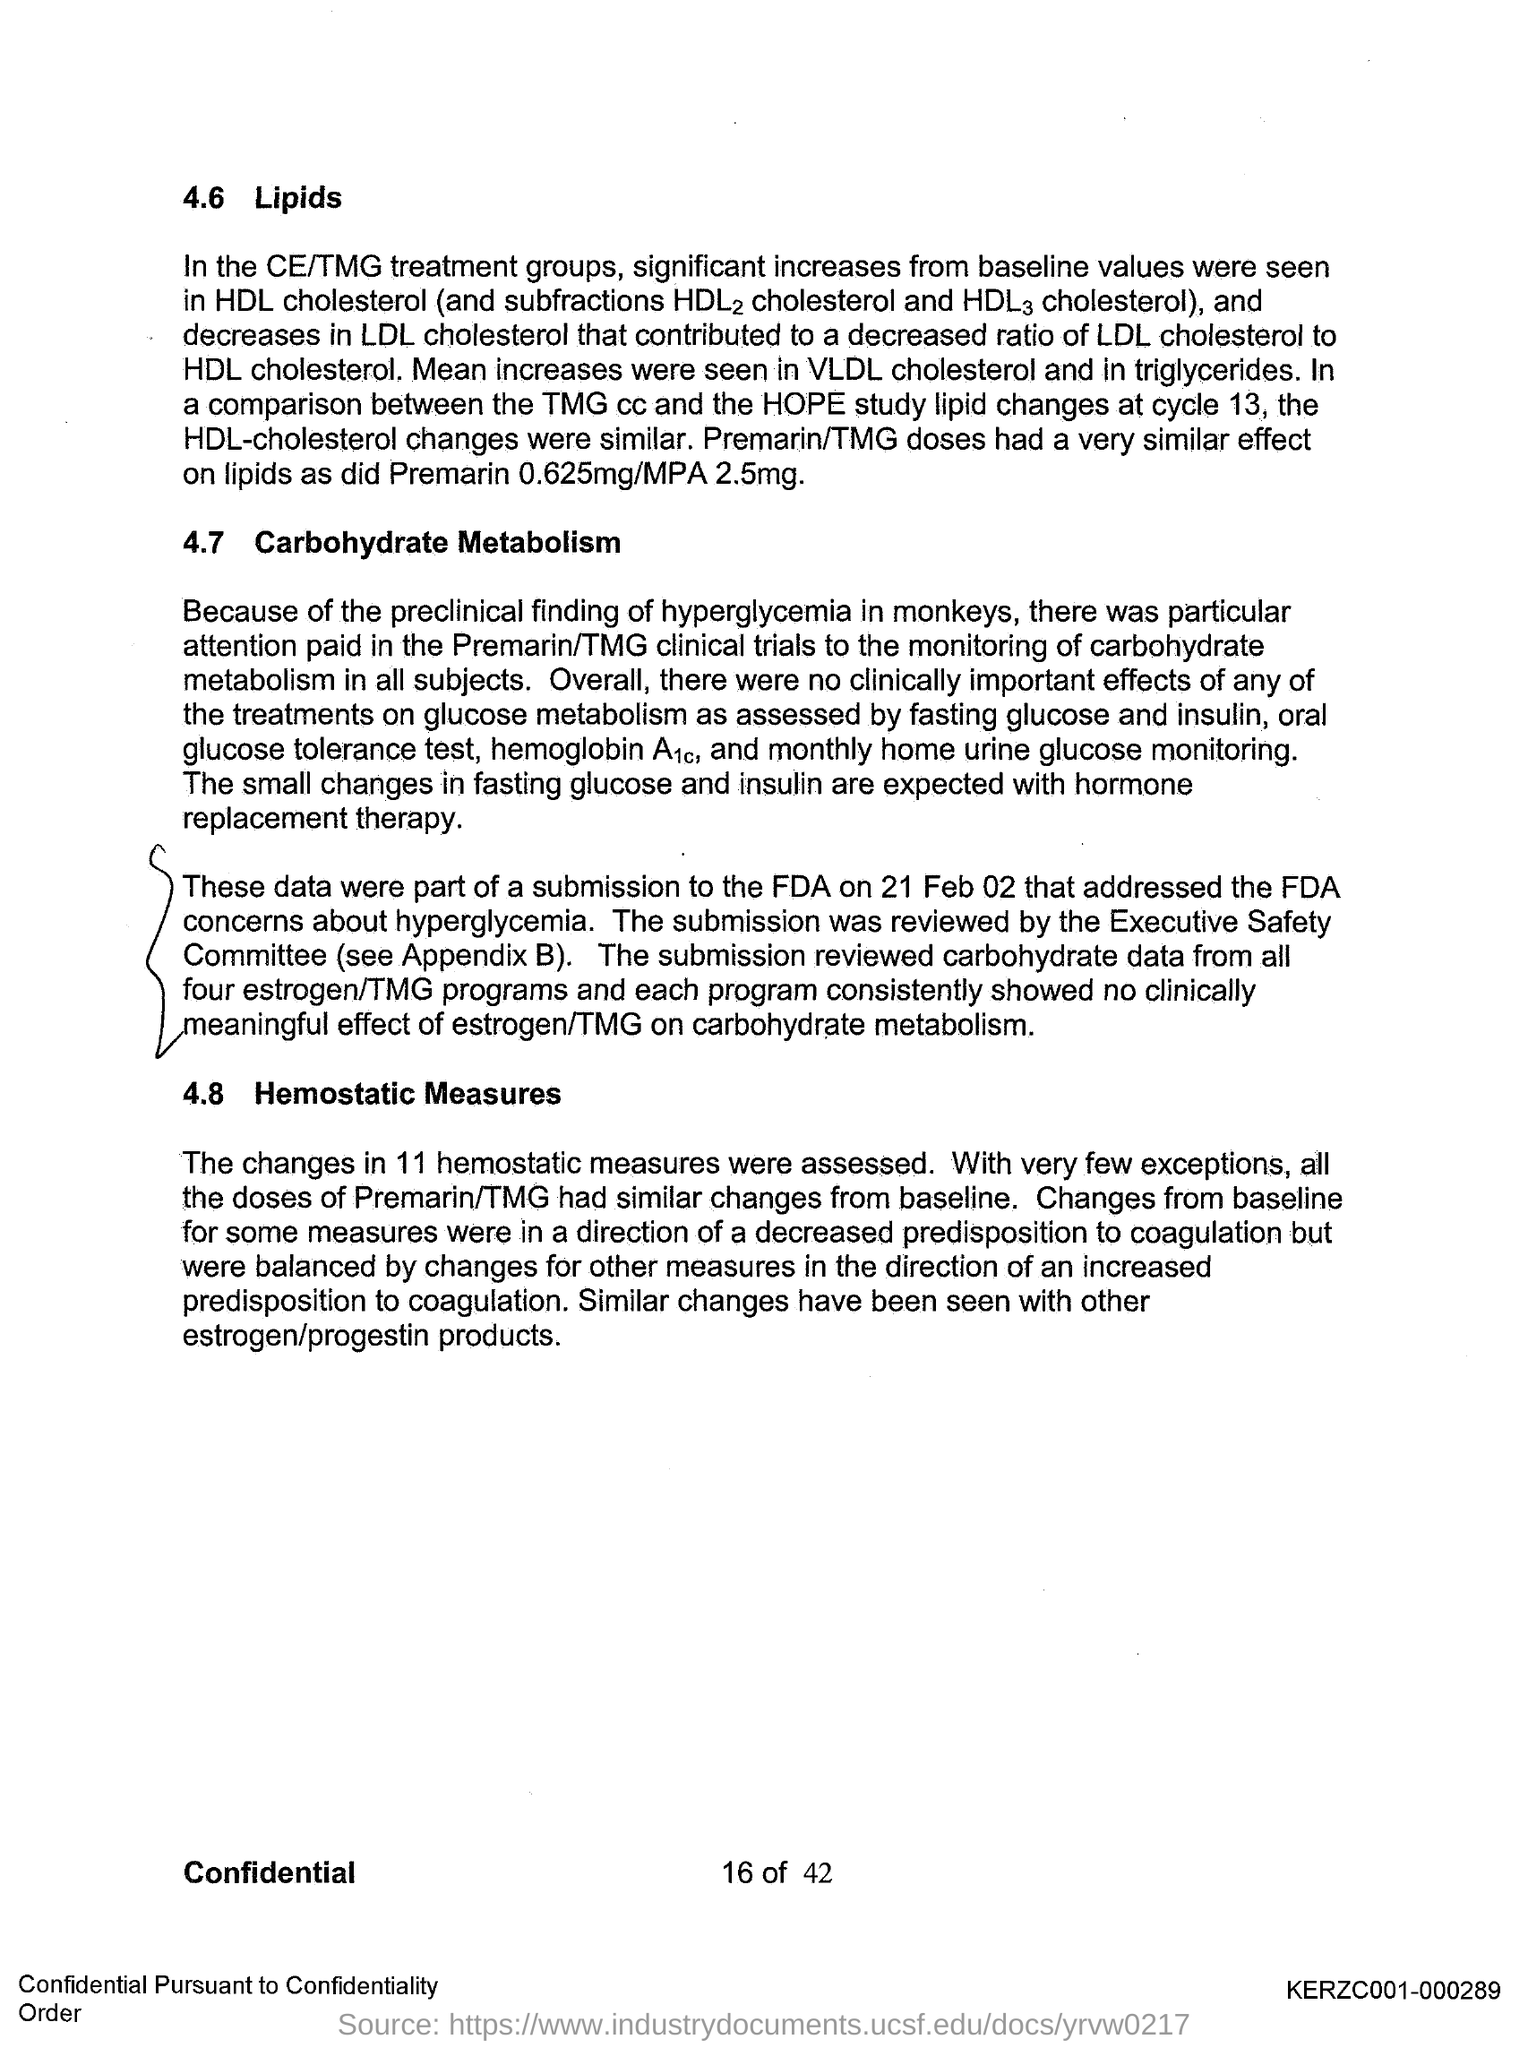Point out several critical features in this image. The first title in the document is "4.6 lipids. The second title in this document is "Carbohydrate Metabolism. 